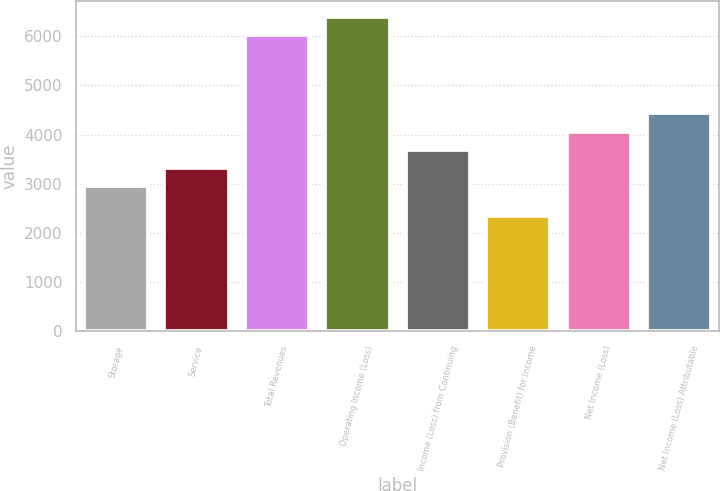<chart> <loc_0><loc_0><loc_500><loc_500><bar_chart><fcel>Storage<fcel>Service<fcel>Total Revenues<fcel>Operating Income (Loss)<fcel>Income (Loss) from Continuing<fcel>Provision (Benefit) for Income<fcel>Net Income (Loss)<fcel>Net Income (Loss) Attributable<nl><fcel>2955<fcel>3323.6<fcel>6023<fcel>6391.6<fcel>3692.2<fcel>2337<fcel>4060.8<fcel>4429.4<nl></chart> 